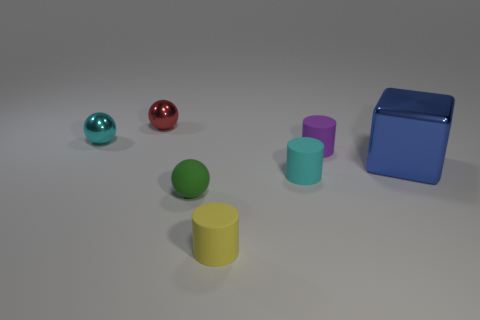Does the cyan thing that is behind the cyan matte cylinder have the same material as the ball to the right of the red object?
Keep it short and to the point. No. What is the material of the purple object?
Your response must be concise. Rubber. Is the color of the tiny matte sphere the same as the metallic cube?
Your response must be concise. No. What number of cyan shiny balls are there?
Make the answer very short. 1. What material is the cyan thing right of the small thing in front of the green rubber object?
Provide a succinct answer. Rubber. What is the material of the yellow object that is the same size as the green rubber sphere?
Offer a very short reply. Rubber. Does the green matte object that is on the right side of the cyan sphere have the same size as the cyan rubber cylinder?
Offer a very short reply. Yes. There is a tiny matte object left of the yellow cylinder; is it the same shape as the cyan metallic thing?
Make the answer very short. Yes. How many things are small brown matte balls or objects that are left of the blue shiny block?
Provide a succinct answer. 6. Are there fewer large rubber things than tiny purple objects?
Make the answer very short. Yes. 